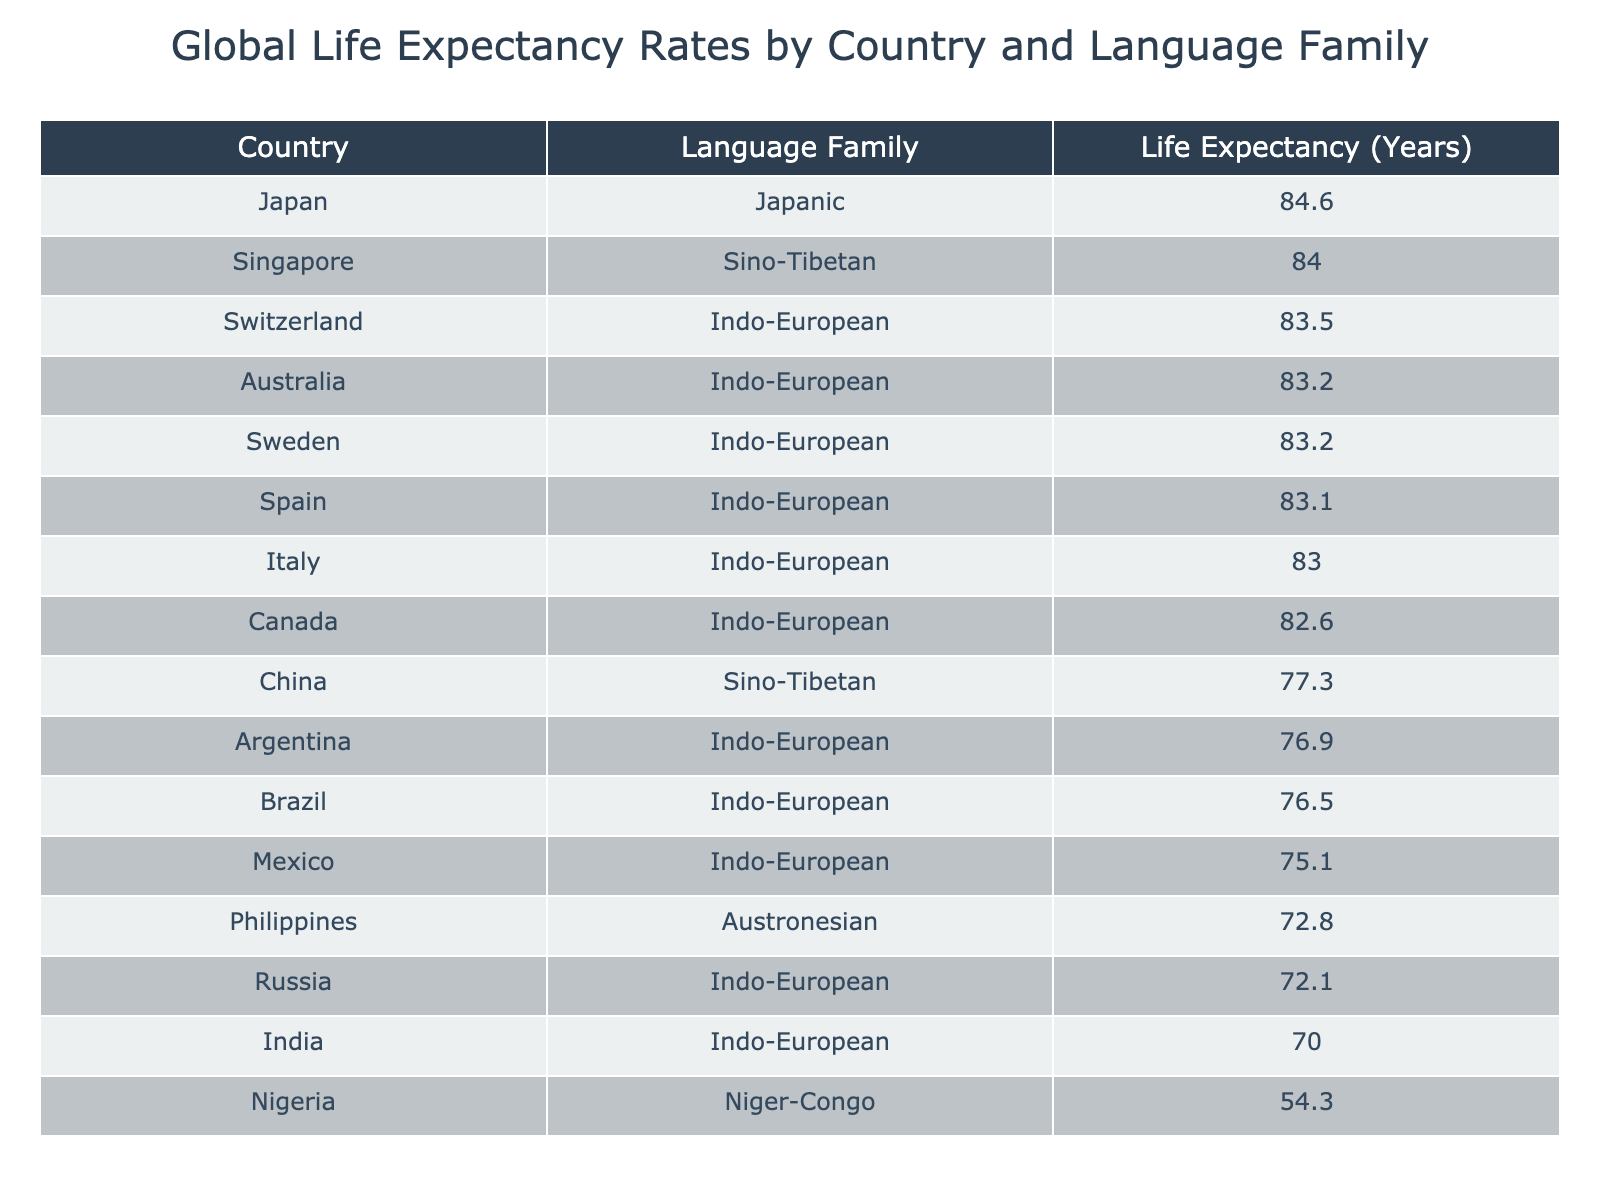What is the life expectancy of Japan? The life expectancy of Japan is directly listed in the table as 84.6 years.
Answer: 84.6 Which country has the lowest life expectancy? The table shows Nigeria has the lowest life expectancy at 54.3 years.
Answer: Nigeria What is the average life expectancy of countries in the Indo-European family? The life expectancy values for Indo-European countries are 83.5, 83.2, 83.1, 83.0, 76.5, 72.1, 82.6, 76.9, 70.0, 75.1. Summing these gives 83.5 + 83.2 + 83.1 + 83.0 + 76.5 + 72.1 + 82.6 + 76.9 + 70.0 + 75.1 =  811.0, then dividing by 10 gives an average of 81.1 years.
Answer: 81.1 Is the life expectancy of China greater than that of Brazil? The table indicates that China's life expectancy is 77.3 years while Brazil's is 76.5 years, which means that it is greater.
Answer: Yes What is the difference in life expectancy between the highest and lowest values in the table? The highest life expectancy is Japan at 84.6 years and the lowest is Nigeria at 54.3 years. To find the difference, subtract: 84.6 - 54.3 = 30.3 years.
Answer: 30.3 How many countries have a life expectancy above 80 years? From the table, the countries with life expectancy above 80 years are Japan, Switzerland, Australia, Singapore, and Sweden. There are 5 such countries.
Answer: 5 Which language family has the highest average life expectancy? To find this, we take the average life expectancy for each language family: Japanic (84.6), Indo-European (81.1), Sino-Tibetan (80.7), Austronesian (72.8), and Niger-Congo (54.3). The highest average is for the Japanic family at 84.6 years.
Answer: Japanic Is the life expectancy of Italy higher than that of the average of all countries in the table? The average life expectancy across all countries can be calculated as (adding all life expectancies: 84.6 + 83.5 + 83.2 + 84.0 + 83.1 + 83.0 + 76.5 + 83.2 + 54.3 + 72.1 + 77.3 + 82.6 + 76.9 + 70.0 + 75.1 + 72.8 = 1274.3) and dividing by 15 gives an average of 84.95 years. Italy's life expectancy is 83.0 years, lower than the average.
Answer: No What is the combined life expectancy of all countries from the Sino-Tibetan language family? The life expectancy values for the Sino-Tibetan family from the table are Singapore at 84.0 years and China at 77.3 years. Combining these gives a total of 84.0 + 77.3 = 161.3 years.
Answer: 161.3 